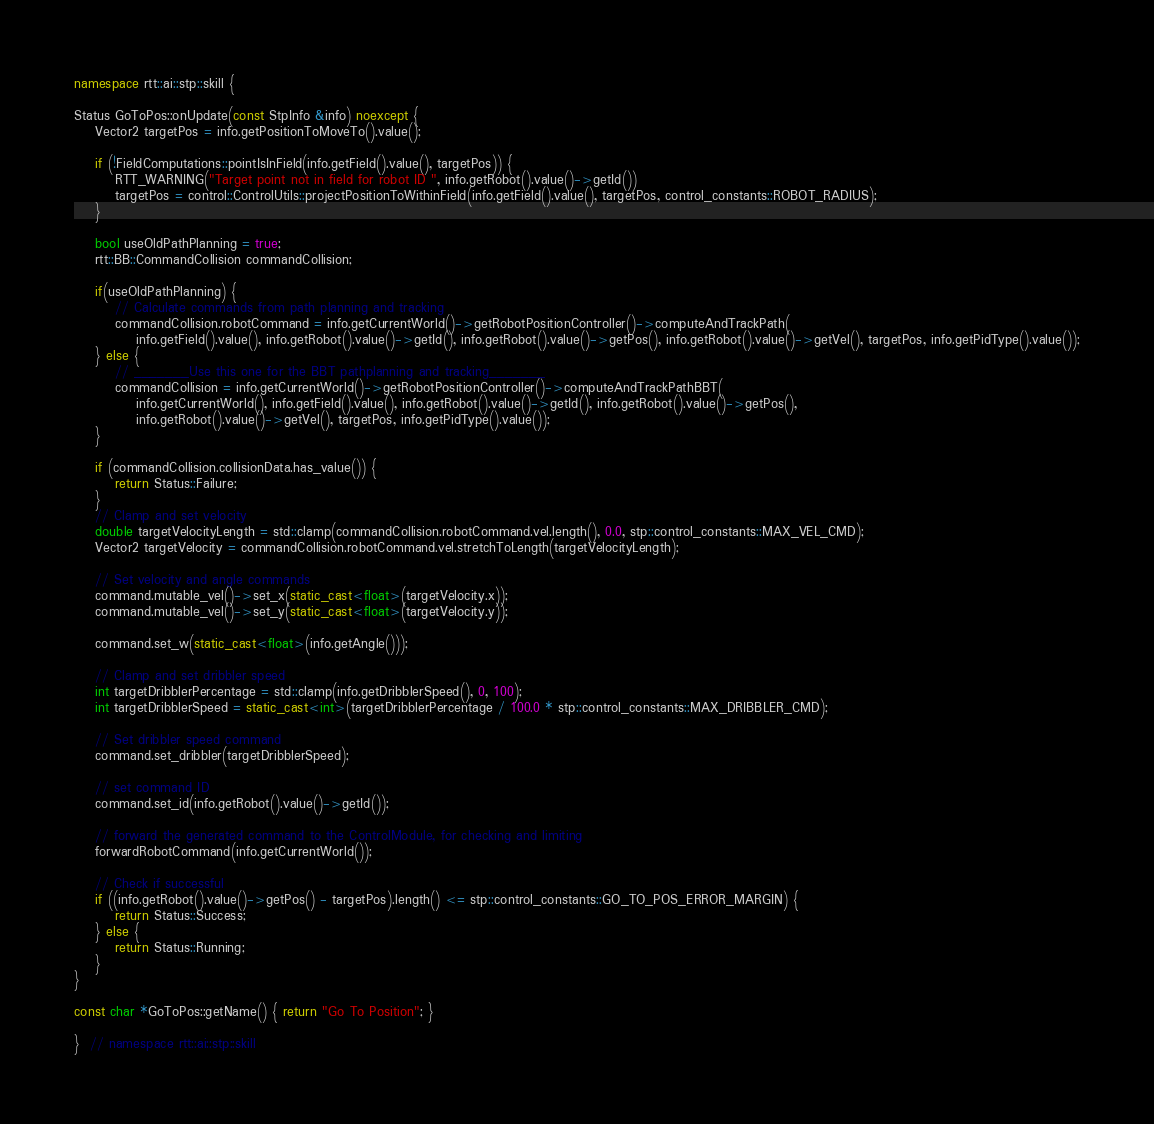<code> <loc_0><loc_0><loc_500><loc_500><_C++_>
namespace rtt::ai::stp::skill {

Status GoToPos::onUpdate(const StpInfo &info) noexcept {
    Vector2 targetPos = info.getPositionToMoveTo().value();

    if (!FieldComputations::pointIsInField(info.getField().value(), targetPos)) {
        RTT_WARNING("Target point not in field for robot ID ", info.getRobot().value()->getId())
        targetPos = control::ControlUtils::projectPositionToWithinField(info.getField().value(), targetPos, control_constants::ROBOT_RADIUS);
    }

    bool useOldPathPlanning = true;
    rtt::BB::CommandCollision commandCollision;

    if(useOldPathPlanning) {
        // Calculate commands from path planning and tracking
        commandCollision.robotCommand = info.getCurrentWorld()->getRobotPositionController()->computeAndTrackPath(
            info.getField().value(), info.getRobot().value()->getId(), info.getRobot().value()->getPos(), info.getRobot().value()->getVel(), targetPos, info.getPidType().value());
    } else {
        // _______Use this one for the BBT pathplanning and tracking_______
        commandCollision = info.getCurrentWorld()->getRobotPositionController()->computeAndTrackPathBBT(
            info.getCurrentWorld(), info.getField().value(), info.getRobot().value()->getId(), info.getRobot().value()->getPos(),
            info.getRobot().value()->getVel(), targetPos, info.getPidType().value());
    }

    if (commandCollision.collisionData.has_value()) {
        return Status::Failure;
    }
    // Clamp and set velocity
    double targetVelocityLength = std::clamp(commandCollision.robotCommand.vel.length(), 0.0, stp::control_constants::MAX_VEL_CMD);
    Vector2 targetVelocity = commandCollision.robotCommand.vel.stretchToLength(targetVelocityLength);

    // Set velocity and angle commands
    command.mutable_vel()->set_x(static_cast<float>(targetVelocity.x));
    command.mutable_vel()->set_y(static_cast<float>(targetVelocity.y));

    command.set_w(static_cast<float>(info.getAngle()));

    // Clamp and set dribbler speed
    int targetDribblerPercentage = std::clamp(info.getDribblerSpeed(), 0, 100);
    int targetDribblerSpeed = static_cast<int>(targetDribblerPercentage / 100.0 * stp::control_constants::MAX_DRIBBLER_CMD);

    // Set dribbler speed command
    command.set_dribbler(targetDribblerSpeed);

    // set command ID
    command.set_id(info.getRobot().value()->getId());

    // forward the generated command to the ControlModule, for checking and limiting
    forwardRobotCommand(info.getCurrentWorld());

    // Check if successful
    if ((info.getRobot().value()->getPos() - targetPos).length() <= stp::control_constants::GO_TO_POS_ERROR_MARGIN) {
        return Status::Success;
    } else {
        return Status::Running;
    }
}

const char *GoToPos::getName() { return "Go To Position"; }

}  // namespace rtt::ai::stp::skill</code> 